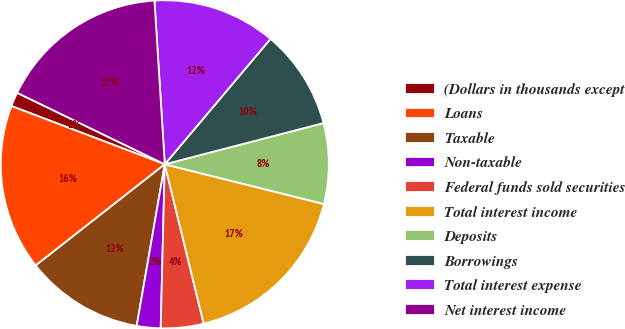Convert chart to OTSL. <chart><loc_0><loc_0><loc_500><loc_500><pie_chart><fcel>(Dollars in thousands except<fcel>Loans<fcel>Taxable<fcel>Non-taxable<fcel>Federal funds sold securities<fcel>Total interest income<fcel>Deposits<fcel>Borrowings<fcel>Total interest expense<fcel>Net interest income<nl><fcel>1.4%<fcel>16.36%<fcel>11.68%<fcel>2.34%<fcel>4.21%<fcel>17.29%<fcel>7.94%<fcel>9.81%<fcel>12.15%<fcel>16.82%<nl></chart> 